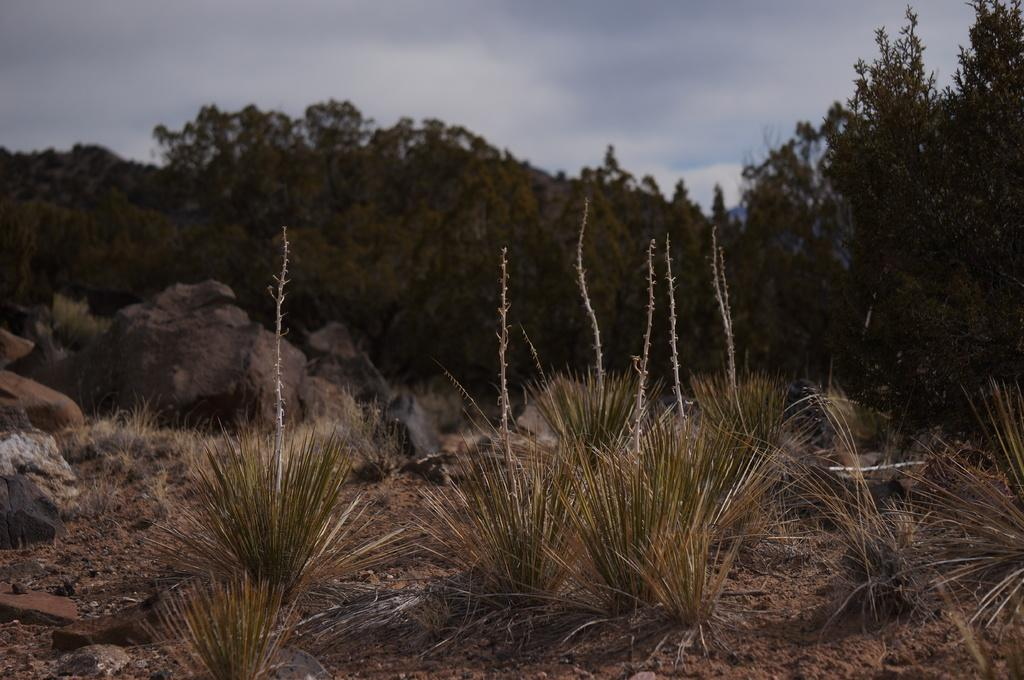What type of surface is visible in the image? There is ground visible in the image. What type of vegetation is present on the ground? There is grass on the ground. What other objects can be seen on the ground? There are rocks in the image. What type of trees are present in the image? There are green trees present in the image. What is visible in the background of the image? The sky is visible in the background of the image. What is the tendency of the rocks to change their size in the image? The rocks do not change their size in the image; they remain stationary. What type of skin can be seen on the trees in the image? There is no skin visible on the trees in the image; they are covered in bark. 